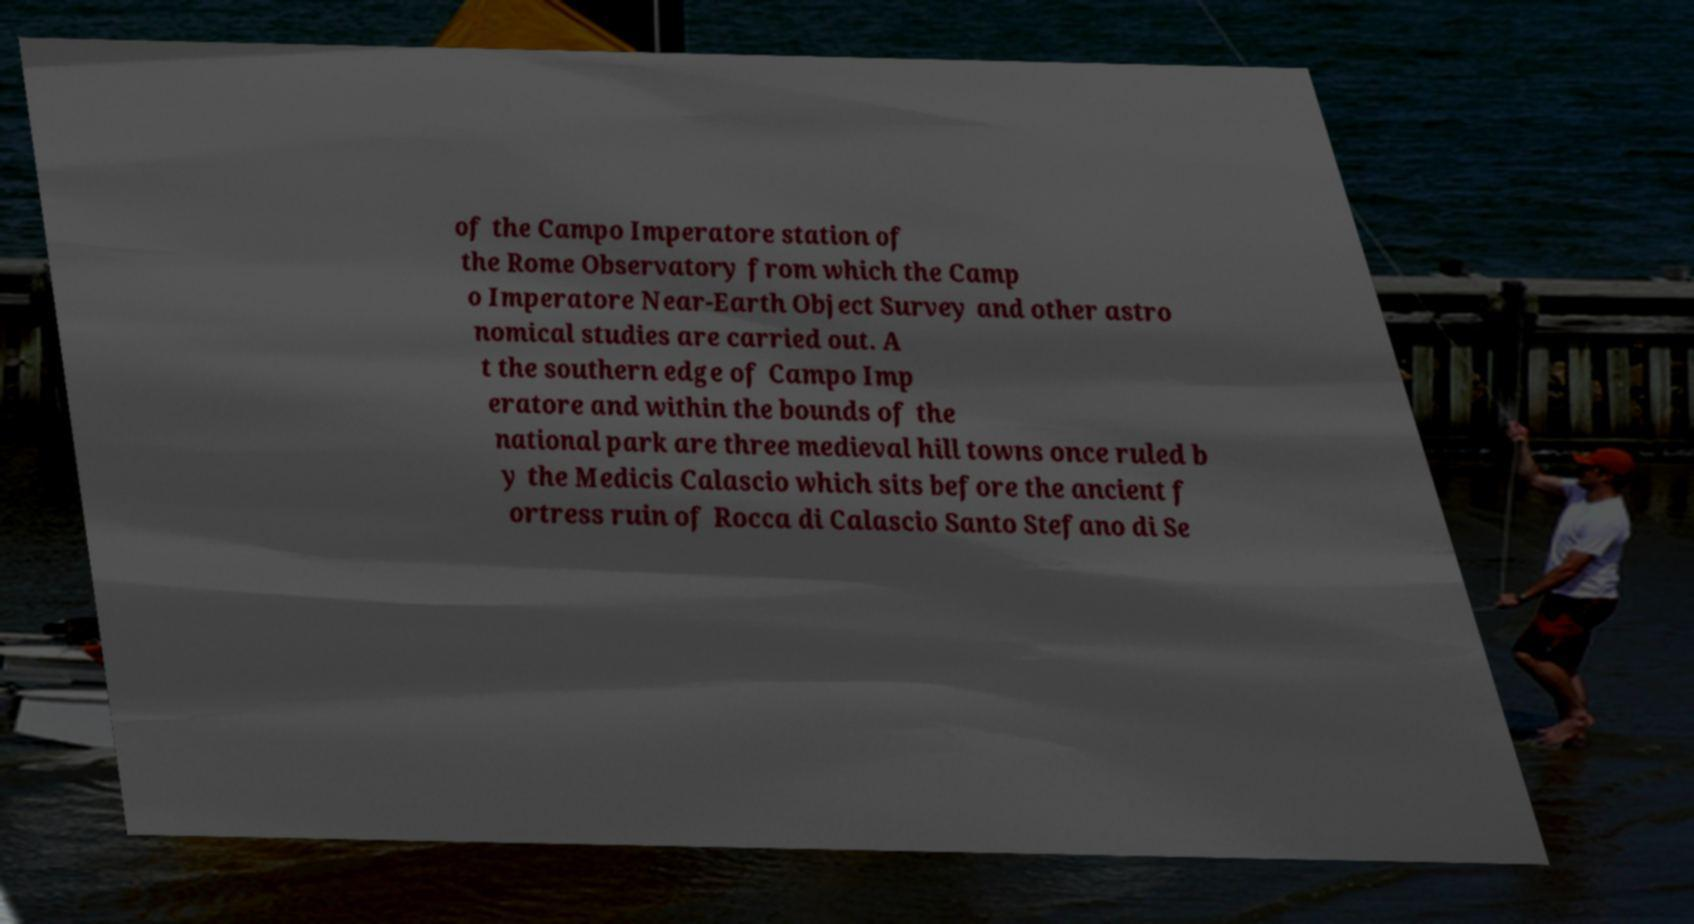There's text embedded in this image that I need extracted. Can you transcribe it verbatim? of the Campo Imperatore station of the Rome Observatory from which the Camp o Imperatore Near-Earth Object Survey and other astro nomical studies are carried out. A t the southern edge of Campo Imp eratore and within the bounds of the national park are three medieval hill towns once ruled b y the Medicis Calascio which sits before the ancient f ortress ruin of Rocca di Calascio Santo Stefano di Se 